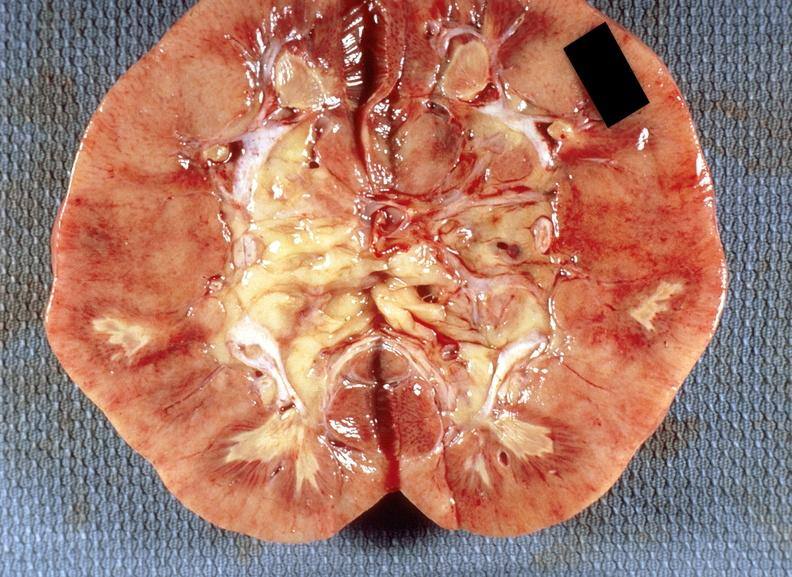does this image show kidney, renal papillary necrosis, acute?
Answer the question using a single word or phrase. Yes 